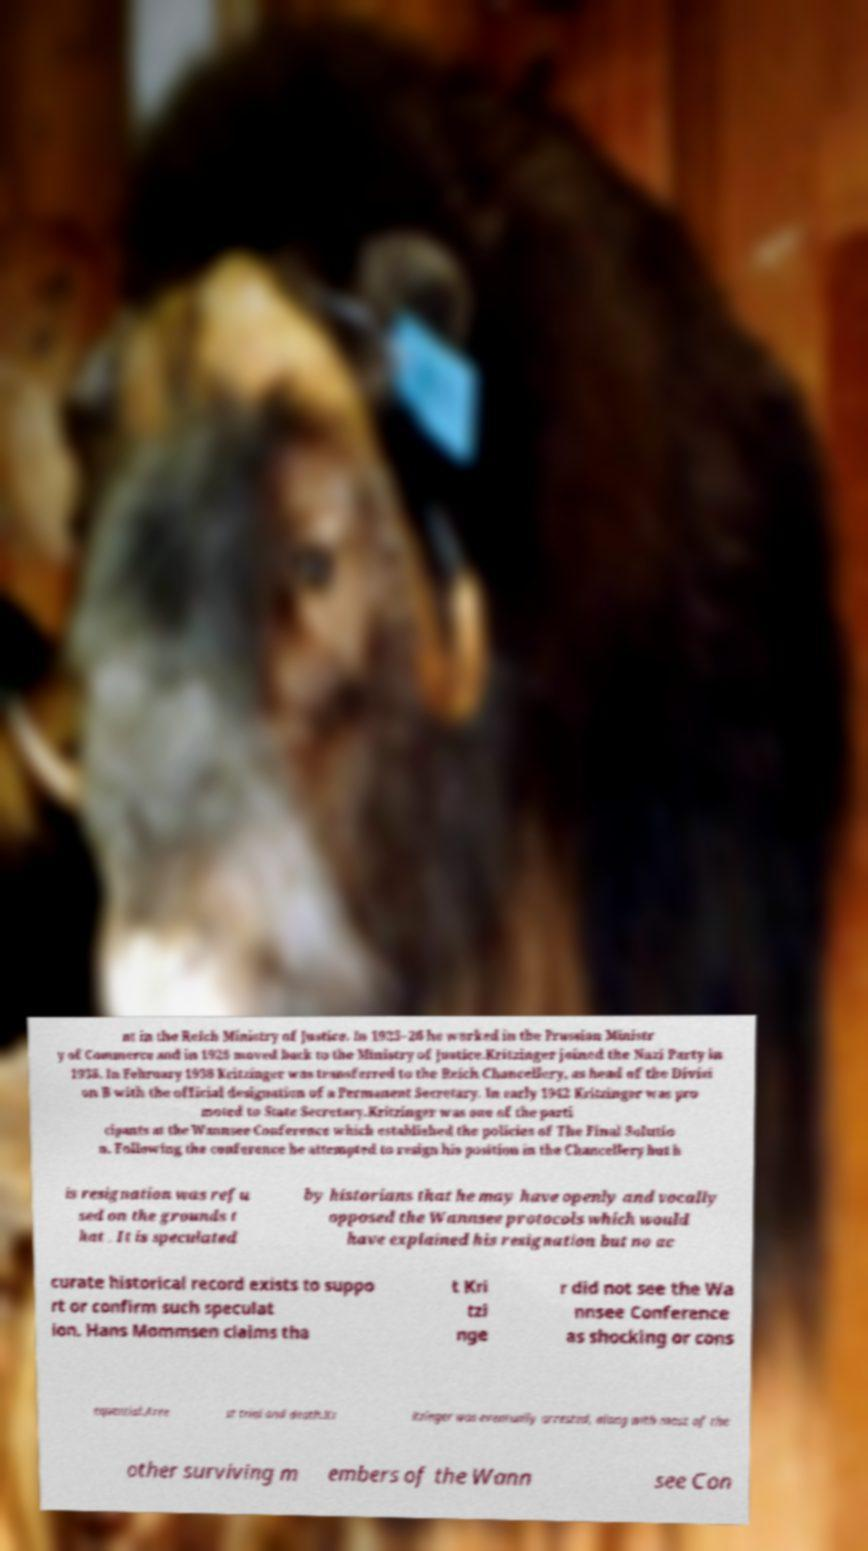Could you assist in decoding the text presented in this image and type it out clearly? nt in the Reich Ministry of Justice. In 1925–26 he worked in the Prussian Ministr y of Commerce and in 1926 moved back to the Ministry of Justice.Kritzinger joined the Nazi Party in 1938. In February 1938 Kritzinger was transferred to the Reich Chancellery, as head of the Divisi on B with the official designation of a Permanent Secretary. In early 1942 Kritzinger was pro moted to State Secretary.Kritzinger was one of the parti cipants at the Wannsee Conference which established the policies of The Final Solutio n. Following the conference he attempted to resign his position in the Chancellery but h is resignation was refu sed on the grounds t hat . It is speculated by historians that he may have openly and vocally opposed the Wannsee protocols which would have explained his resignation but no ac curate historical record exists to suppo rt or confirm such speculat ion. Hans Mommsen claims tha t Kri tzi nge r did not see the Wa nnsee Conference as shocking or cons equential.Arre st trial and death.Kr itzinger was eventually arrested, along with most of the other surviving m embers of the Wann see Con 